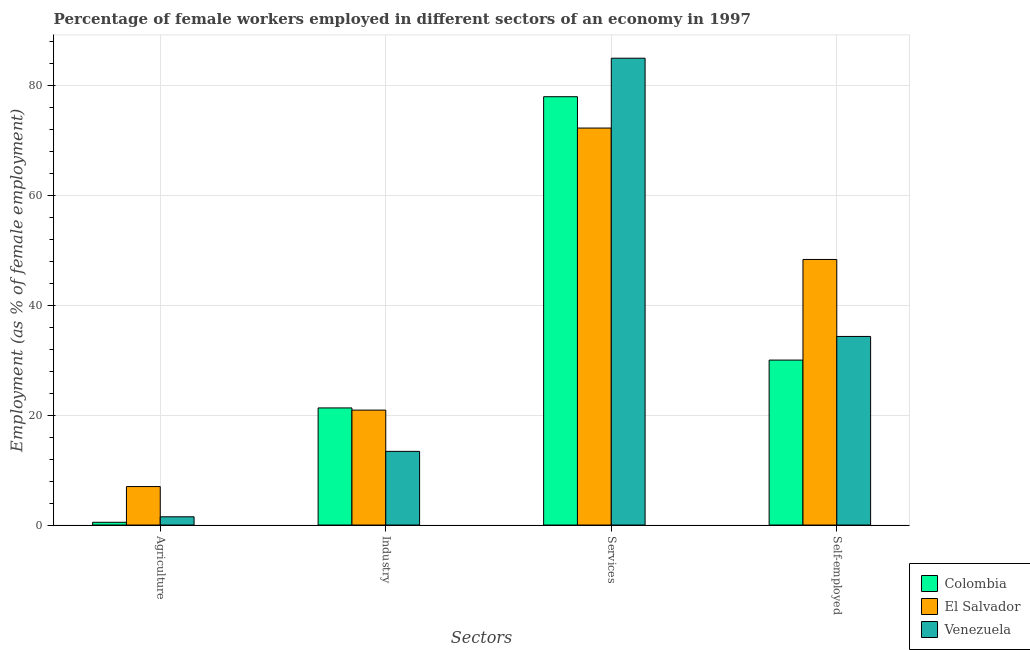How many groups of bars are there?
Provide a short and direct response. 4. Are the number of bars per tick equal to the number of legend labels?
Provide a succinct answer. Yes. How many bars are there on the 4th tick from the left?
Offer a very short reply. 3. What is the label of the 3rd group of bars from the left?
Your answer should be very brief. Services. What is the percentage of female workers in services in Venezuela?
Keep it short and to the point. 84.9. Across all countries, what is the maximum percentage of self employed female workers?
Your answer should be very brief. 48.3. Across all countries, what is the minimum percentage of female workers in industry?
Provide a succinct answer. 13.4. In which country was the percentage of female workers in services maximum?
Provide a succinct answer. Venezuela. What is the total percentage of female workers in agriculture in the graph?
Your answer should be very brief. 9. What is the difference between the percentage of female workers in agriculture in Venezuela and that in Colombia?
Your answer should be compact. 1. What is the difference between the percentage of self employed female workers in Venezuela and the percentage of female workers in industry in Colombia?
Offer a very short reply. 13. What is the average percentage of female workers in industry per country?
Give a very brief answer. 18.53. What is the difference between the percentage of female workers in industry and percentage of self employed female workers in Venezuela?
Ensure brevity in your answer.  -20.9. In how many countries, is the percentage of female workers in services greater than 36 %?
Offer a terse response. 3. What is the ratio of the percentage of female workers in agriculture in Colombia to that in Venezuela?
Provide a short and direct response. 0.33. Is the difference between the percentage of female workers in agriculture in El Salvador and Venezuela greater than the difference between the percentage of female workers in industry in El Salvador and Venezuela?
Your response must be concise. No. What is the difference between the highest and the lowest percentage of female workers in industry?
Offer a terse response. 7.9. In how many countries, is the percentage of female workers in industry greater than the average percentage of female workers in industry taken over all countries?
Offer a terse response. 2. Is it the case that in every country, the sum of the percentage of female workers in services and percentage of female workers in agriculture is greater than the sum of percentage of self employed female workers and percentage of female workers in industry?
Make the answer very short. Yes. What does the 3rd bar from the left in Self-employed represents?
Make the answer very short. Venezuela. What is the difference between two consecutive major ticks on the Y-axis?
Ensure brevity in your answer.  20. Are the values on the major ticks of Y-axis written in scientific E-notation?
Your answer should be compact. No. Where does the legend appear in the graph?
Provide a short and direct response. Bottom right. How many legend labels are there?
Offer a terse response. 3. How are the legend labels stacked?
Offer a very short reply. Vertical. What is the title of the graph?
Offer a very short reply. Percentage of female workers employed in different sectors of an economy in 1997. What is the label or title of the X-axis?
Your response must be concise. Sectors. What is the label or title of the Y-axis?
Offer a terse response. Employment (as % of female employment). What is the Employment (as % of female employment) in Colombia in Agriculture?
Offer a very short reply. 0.5. What is the Employment (as % of female employment) in Venezuela in Agriculture?
Offer a terse response. 1.5. What is the Employment (as % of female employment) of Colombia in Industry?
Provide a short and direct response. 21.3. What is the Employment (as % of female employment) of El Salvador in Industry?
Provide a succinct answer. 20.9. What is the Employment (as % of female employment) in Venezuela in Industry?
Provide a short and direct response. 13.4. What is the Employment (as % of female employment) in Colombia in Services?
Provide a short and direct response. 77.9. What is the Employment (as % of female employment) in El Salvador in Services?
Provide a short and direct response. 72.2. What is the Employment (as % of female employment) in Venezuela in Services?
Offer a very short reply. 84.9. What is the Employment (as % of female employment) in Colombia in Self-employed?
Your answer should be very brief. 30. What is the Employment (as % of female employment) in El Salvador in Self-employed?
Your answer should be very brief. 48.3. What is the Employment (as % of female employment) in Venezuela in Self-employed?
Ensure brevity in your answer.  34.3. Across all Sectors, what is the maximum Employment (as % of female employment) of Colombia?
Your answer should be very brief. 77.9. Across all Sectors, what is the maximum Employment (as % of female employment) in El Salvador?
Your answer should be compact. 72.2. Across all Sectors, what is the maximum Employment (as % of female employment) of Venezuela?
Make the answer very short. 84.9. Across all Sectors, what is the minimum Employment (as % of female employment) of El Salvador?
Your answer should be compact. 7. What is the total Employment (as % of female employment) of Colombia in the graph?
Provide a short and direct response. 129.7. What is the total Employment (as % of female employment) of El Salvador in the graph?
Provide a short and direct response. 148.4. What is the total Employment (as % of female employment) of Venezuela in the graph?
Offer a very short reply. 134.1. What is the difference between the Employment (as % of female employment) in Colombia in Agriculture and that in Industry?
Offer a terse response. -20.8. What is the difference between the Employment (as % of female employment) of El Salvador in Agriculture and that in Industry?
Provide a succinct answer. -13.9. What is the difference between the Employment (as % of female employment) of Colombia in Agriculture and that in Services?
Provide a short and direct response. -77.4. What is the difference between the Employment (as % of female employment) of El Salvador in Agriculture and that in Services?
Your answer should be compact. -65.2. What is the difference between the Employment (as % of female employment) in Venezuela in Agriculture and that in Services?
Your response must be concise. -83.4. What is the difference between the Employment (as % of female employment) in Colombia in Agriculture and that in Self-employed?
Your answer should be very brief. -29.5. What is the difference between the Employment (as % of female employment) in El Salvador in Agriculture and that in Self-employed?
Keep it short and to the point. -41.3. What is the difference between the Employment (as % of female employment) of Venezuela in Agriculture and that in Self-employed?
Provide a succinct answer. -32.8. What is the difference between the Employment (as % of female employment) of Colombia in Industry and that in Services?
Ensure brevity in your answer.  -56.6. What is the difference between the Employment (as % of female employment) of El Salvador in Industry and that in Services?
Provide a short and direct response. -51.3. What is the difference between the Employment (as % of female employment) in Venezuela in Industry and that in Services?
Keep it short and to the point. -71.5. What is the difference between the Employment (as % of female employment) in Colombia in Industry and that in Self-employed?
Your response must be concise. -8.7. What is the difference between the Employment (as % of female employment) in El Salvador in Industry and that in Self-employed?
Offer a very short reply. -27.4. What is the difference between the Employment (as % of female employment) of Venezuela in Industry and that in Self-employed?
Provide a short and direct response. -20.9. What is the difference between the Employment (as % of female employment) of Colombia in Services and that in Self-employed?
Your response must be concise. 47.9. What is the difference between the Employment (as % of female employment) of El Salvador in Services and that in Self-employed?
Ensure brevity in your answer.  23.9. What is the difference between the Employment (as % of female employment) of Venezuela in Services and that in Self-employed?
Give a very brief answer. 50.6. What is the difference between the Employment (as % of female employment) in Colombia in Agriculture and the Employment (as % of female employment) in El Salvador in Industry?
Make the answer very short. -20.4. What is the difference between the Employment (as % of female employment) of Colombia in Agriculture and the Employment (as % of female employment) of Venezuela in Industry?
Give a very brief answer. -12.9. What is the difference between the Employment (as % of female employment) of El Salvador in Agriculture and the Employment (as % of female employment) of Venezuela in Industry?
Ensure brevity in your answer.  -6.4. What is the difference between the Employment (as % of female employment) of Colombia in Agriculture and the Employment (as % of female employment) of El Salvador in Services?
Keep it short and to the point. -71.7. What is the difference between the Employment (as % of female employment) of Colombia in Agriculture and the Employment (as % of female employment) of Venezuela in Services?
Offer a very short reply. -84.4. What is the difference between the Employment (as % of female employment) in El Salvador in Agriculture and the Employment (as % of female employment) in Venezuela in Services?
Keep it short and to the point. -77.9. What is the difference between the Employment (as % of female employment) of Colombia in Agriculture and the Employment (as % of female employment) of El Salvador in Self-employed?
Make the answer very short. -47.8. What is the difference between the Employment (as % of female employment) of Colombia in Agriculture and the Employment (as % of female employment) of Venezuela in Self-employed?
Offer a very short reply. -33.8. What is the difference between the Employment (as % of female employment) of El Salvador in Agriculture and the Employment (as % of female employment) of Venezuela in Self-employed?
Your answer should be very brief. -27.3. What is the difference between the Employment (as % of female employment) of Colombia in Industry and the Employment (as % of female employment) of El Salvador in Services?
Provide a succinct answer. -50.9. What is the difference between the Employment (as % of female employment) in Colombia in Industry and the Employment (as % of female employment) in Venezuela in Services?
Your answer should be compact. -63.6. What is the difference between the Employment (as % of female employment) in El Salvador in Industry and the Employment (as % of female employment) in Venezuela in Services?
Offer a very short reply. -64. What is the difference between the Employment (as % of female employment) in Colombia in Industry and the Employment (as % of female employment) in El Salvador in Self-employed?
Provide a short and direct response. -27. What is the difference between the Employment (as % of female employment) in Colombia in Services and the Employment (as % of female employment) in El Salvador in Self-employed?
Provide a succinct answer. 29.6. What is the difference between the Employment (as % of female employment) of Colombia in Services and the Employment (as % of female employment) of Venezuela in Self-employed?
Give a very brief answer. 43.6. What is the difference between the Employment (as % of female employment) of El Salvador in Services and the Employment (as % of female employment) of Venezuela in Self-employed?
Provide a succinct answer. 37.9. What is the average Employment (as % of female employment) in Colombia per Sectors?
Your answer should be compact. 32.42. What is the average Employment (as % of female employment) of El Salvador per Sectors?
Provide a succinct answer. 37.1. What is the average Employment (as % of female employment) of Venezuela per Sectors?
Ensure brevity in your answer.  33.52. What is the difference between the Employment (as % of female employment) of El Salvador and Employment (as % of female employment) of Venezuela in Agriculture?
Ensure brevity in your answer.  5.5. What is the difference between the Employment (as % of female employment) in Colombia and Employment (as % of female employment) in Venezuela in Industry?
Provide a short and direct response. 7.9. What is the difference between the Employment (as % of female employment) in Colombia and Employment (as % of female employment) in El Salvador in Services?
Keep it short and to the point. 5.7. What is the difference between the Employment (as % of female employment) in Colombia and Employment (as % of female employment) in El Salvador in Self-employed?
Ensure brevity in your answer.  -18.3. What is the difference between the Employment (as % of female employment) of Colombia and Employment (as % of female employment) of Venezuela in Self-employed?
Your answer should be compact. -4.3. What is the difference between the Employment (as % of female employment) of El Salvador and Employment (as % of female employment) of Venezuela in Self-employed?
Provide a succinct answer. 14. What is the ratio of the Employment (as % of female employment) in Colombia in Agriculture to that in Industry?
Keep it short and to the point. 0.02. What is the ratio of the Employment (as % of female employment) of El Salvador in Agriculture to that in Industry?
Your answer should be compact. 0.33. What is the ratio of the Employment (as % of female employment) in Venezuela in Agriculture to that in Industry?
Your answer should be very brief. 0.11. What is the ratio of the Employment (as % of female employment) in Colombia in Agriculture to that in Services?
Offer a terse response. 0.01. What is the ratio of the Employment (as % of female employment) of El Salvador in Agriculture to that in Services?
Provide a succinct answer. 0.1. What is the ratio of the Employment (as % of female employment) in Venezuela in Agriculture to that in Services?
Your answer should be compact. 0.02. What is the ratio of the Employment (as % of female employment) in Colombia in Agriculture to that in Self-employed?
Make the answer very short. 0.02. What is the ratio of the Employment (as % of female employment) in El Salvador in Agriculture to that in Self-employed?
Your answer should be compact. 0.14. What is the ratio of the Employment (as % of female employment) in Venezuela in Agriculture to that in Self-employed?
Keep it short and to the point. 0.04. What is the ratio of the Employment (as % of female employment) in Colombia in Industry to that in Services?
Offer a very short reply. 0.27. What is the ratio of the Employment (as % of female employment) of El Salvador in Industry to that in Services?
Provide a succinct answer. 0.29. What is the ratio of the Employment (as % of female employment) in Venezuela in Industry to that in Services?
Your answer should be very brief. 0.16. What is the ratio of the Employment (as % of female employment) in Colombia in Industry to that in Self-employed?
Your answer should be very brief. 0.71. What is the ratio of the Employment (as % of female employment) in El Salvador in Industry to that in Self-employed?
Your answer should be compact. 0.43. What is the ratio of the Employment (as % of female employment) in Venezuela in Industry to that in Self-employed?
Your answer should be compact. 0.39. What is the ratio of the Employment (as % of female employment) in Colombia in Services to that in Self-employed?
Give a very brief answer. 2.6. What is the ratio of the Employment (as % of female employment) in El Salvador in Services to that in Self-employed?
Provide a succinct answer. 1.49. What is the ratio of the Employment (as % of female employment) of Venezuela in Services to that in Self-employed?
Give a very brief answer. 2.48. What is the difference between the highest and the second highest Employment (as % of female employment) of Colombia?
Your answer should be very brief. 47.9. What is the difference between the highest and the second highest Employment (as % of female employment) in El Salvador?
Give a very brief answer. 23.9. What is the difference between the highest and the second highest Employment (as % of female employment) of Venezuela?
Make the answer very short. 50.6. What is the difference between the highest and the lowest Employment (as % of female employment) of Colombia?
Offer a very short reply. 77.4. What is the difference between the highest and the lowest Employment (as % of female employment) in El Salvador?
Make the answer very short. 65.2. What is the difference between the highest and the lowest Employment (as % of female employment) of Venezuela?
Offer a terse response. 83.4. 